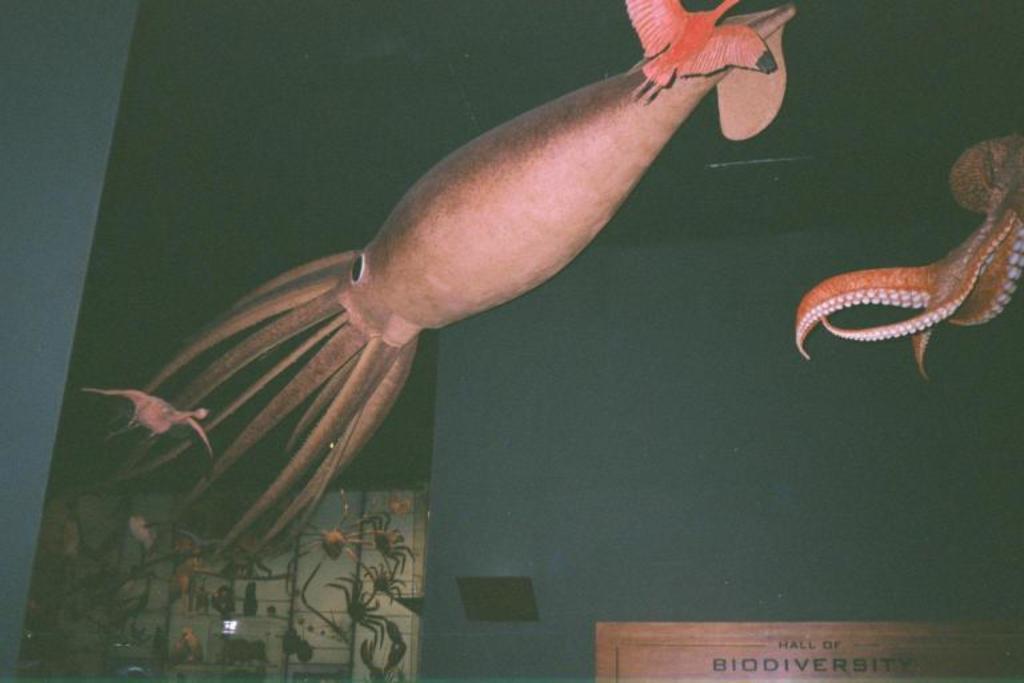How would you summarize this image in a sentence or two? On the right side of the image we can see an octopus, and we can find a board at the right bottom of the image, and we can see few insects and it is looks like a fish. 